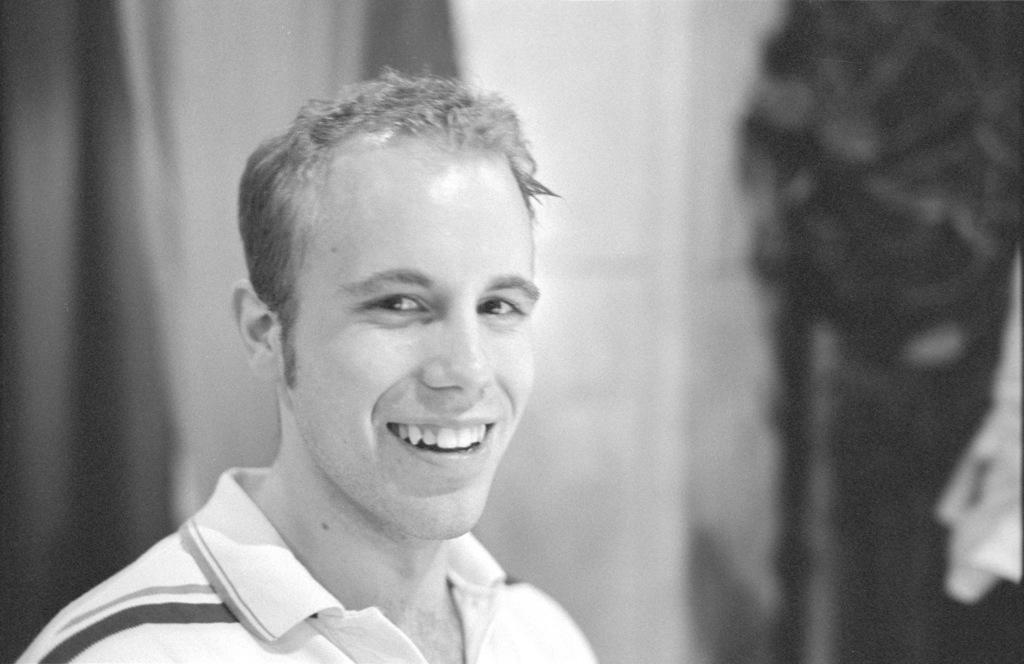In one or two sentences, can you explain what this image depicts? This is a black and white image. In this image, we can see a man. In the background, we can see white color and black color. 